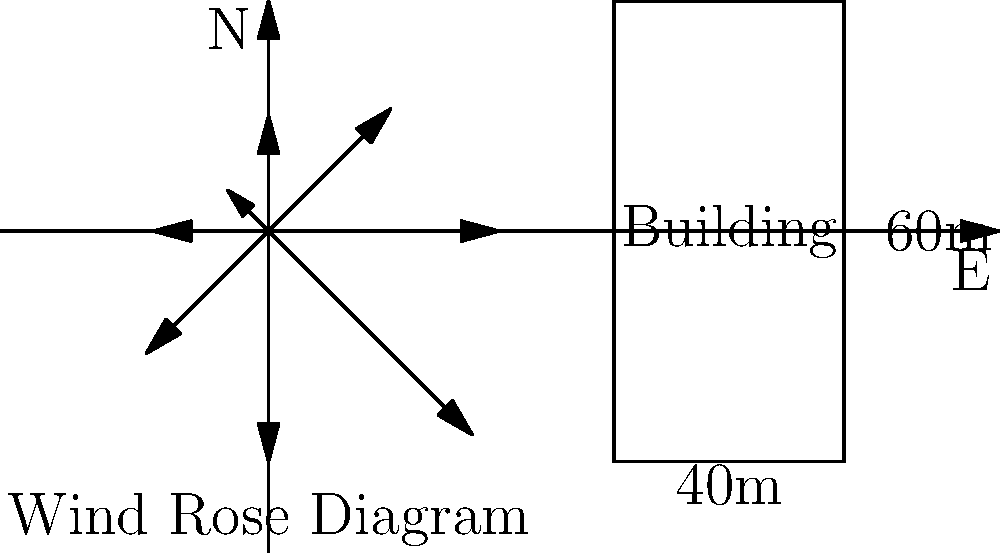As an innovative start-up founder, you're designing a sustainable high-rise building. Using the wind rose diagram and building dimensions provided, calculate the maximum wind load on the building's face. Assume a drag coefficient of 1.4 and air density of 1.225 kg/m³. Which wind direction produces the highest load? To solve this problem, we'll follow these steps:

1. Identify the maximum wind speed from the wind rose diagram.
2. Calculate the wind pressure using the formula: $P = \frac{1}{2} \rho v^2 C_d$
3. Determine the area of the building face.
4. Calculate the wind load using $F = P \times A$

Step 1: The maximum wind speed is 25 m/s from the 315° direction (NW).

Step 2: Calculate wind pressure:
$P = \frac{1}{2} \rho v^2 C_d$
$P = \frac{1}{2} \times 1.225 \text{ kg/m³} \times (25 \text{ m/s})^2 \times 1.4$
$P = 534.84 \text{ Pa}$

Step 3: The building dimensions are 40m x 60m. The area facing the wind is:
$A = 40 \text{ m} \times 60 \text{ m} = 2400 \text{ m}^2$

Step 4: Calculate the wind load:
$F = P \times A$
$F = 534.84 \text{ Pa} \times 2400 \text{ m}^2$
$F = 1,283,616 \text{ N} = 1283.62 \text{ kN}$

Therefore, the maximum wind load occurs from the 315° direction (NW) and is approximately 1283.62 kN.
Answer: 315° (NW), 1283.62 kN 